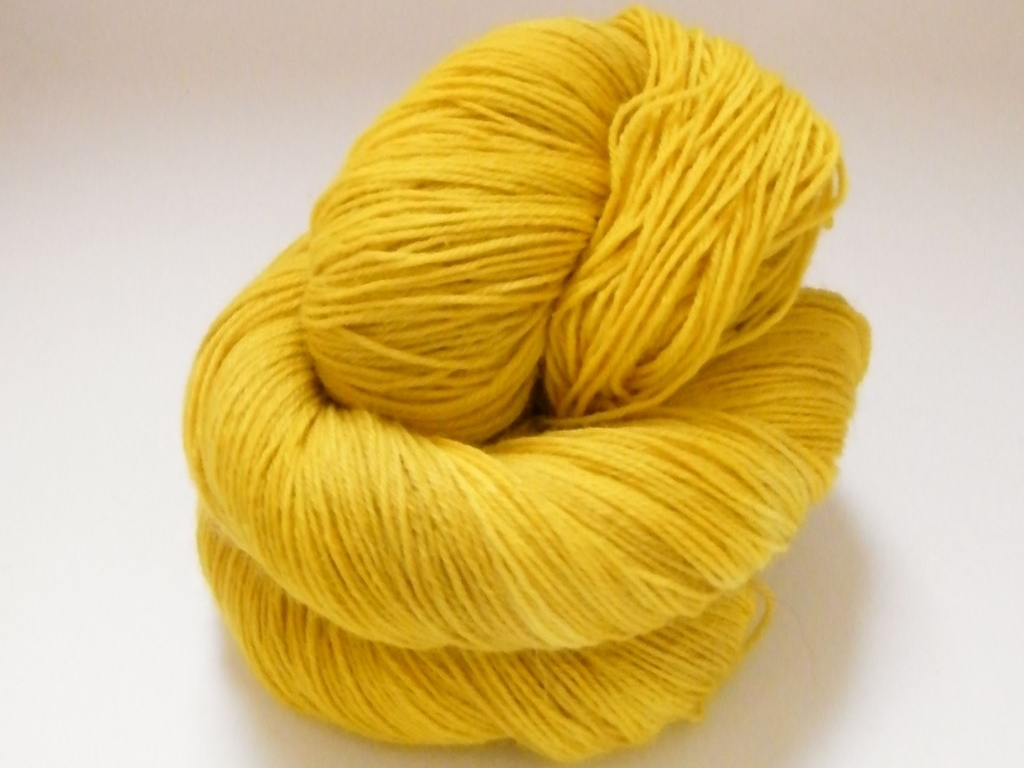Overall, how would you rate the image quality?
A. Good
B. Poor
C. Average
Answer with the option's letter from the given choices directly.
 A. 